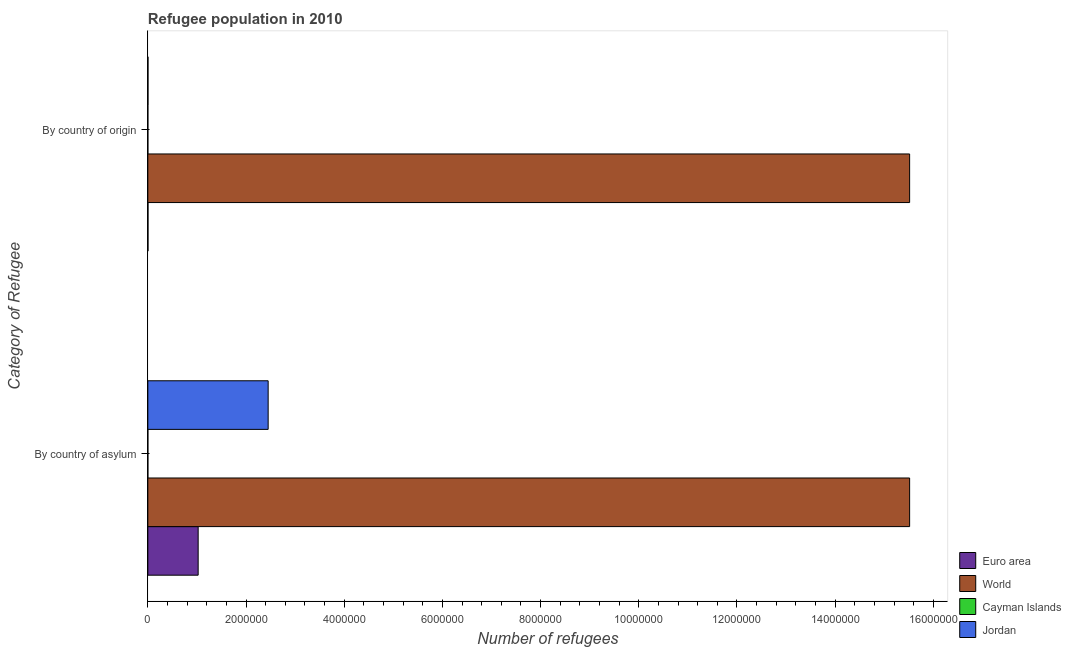How many groups of bars are there?
Ensure brevity in your answer.  2. Are the number of bars per tick equal to the number of legend labels?
Provide a succinct answer. Yes. Are the number of bars on each tick of the Y-axis equal?
Ensure brevity in your answer.  Yes. How many bars are there on the 2nd tick from the top?
Your answer should be compact. 4. How many bars are there on the 2nd tick from the bottom?
Your answer should be very brief. 4. What is the label of the 1st group of bars from the top?
Your response must be concise. By country of origin. What is the number of refugees by country of asylum in Cayman Islands?
Keep it short and to the point. 1. Across all countries, what is the maximum number of refugees by country of asylum?
Offer a terse response. 1.55e+07. Across all countries, what is the minimum number of refugees by country of origin?
Keep it short and to the point. 1. In which country was the number of refugees by country of origin minimum?
Make the answer very short. Cayman Islands. What is the total number of refugees by country of origin in the graph?
Ensure brevity in your answer.  1.55e+07. What is the difference between the number of refugees by country of asylum in Cayman Islands and that in World?
Ensure brevity in your answer.  -1.55e+07. What is the difference between the number of refugees by country of origin in World and the number of refugees by country of asylum in Cayman Islands?
Give a very brief answer. 1.55e+07. What is the average number of refugees by country of asylum per country?
Keep it short and to the point. 4.75e+06. What is the difference between the number of refugees by country of origin and number of refugees by country of asylum in Jordan?
Provide a succinct answer. -2.45e+06. In how many countries, is the number of refugees by country of origin greater than 14400000 ?
Provide a succinct answer. 1. What is the ratio of the number of refugees by country of origin in Jordan to that in Cayman Islands?
Your response must be concise. 2254. What does the 1st bar from the top in By country of origin represents?
Your answer should be very brief. Jordan. How many bars are there?
Your response must be concise. 8. How many countries are there in the graph?
Keep it short and to the point. 4. What is the difference between two consecutive major ticks on the X-axis?
Keep it short and to the point. 2.00e+06. Are the values on the major ticks of X-axis written in scientific E-notation?
Provide a short and direct response. No. Does the graph contain any zero values?
Your answer should be compact. No. How are the legend labels stacked?
Offer a terse response. Vertical. What is the title of the graph?
Make the answer very short. Refugee population in 2010. What is the label or title of the X-axis?
Make the answer very short. Number of refugees. What is the label or title of the Y-axis?
Your response must be concise. Category of Refugee. What is the Number of refugees in Euro area in By country of asylum?
Your answer should be compact. 1.02e+06. What is the Number of refugees in World in By country of asylum?
Offer a very short reply. 1.55e+07. What is the Number of refugees in Jordan in By country of asylum?
Offer a terse response. 2.45e+06. What is the Number of refugees of Euro area in By country of origin?
Make the answer very short. 2272. What is the Number of refugees in World in By country of origin?
Make the answer very short. 1.55e+07. What is the Number of refugees in Cayman Islands in By country of origin?
Make the answer very short. 1. What is the Number of refugees of Jordan in By country of origin?
Your answer should be very brief. 2254. Across all Category of Refugee, what is the maximum Number of refugees of Euro area?
Offer a very short reply. 1.02e+06. Across all Category of Refugee, what is the maximum Number of refugees in World?
Your answer should be very brief. 1.55e+07. Across all Category of Refugee, what is the maximum Number of refugees of Cayman Islands?
Keep it short and to the point. 1. Across all Category of Refugee, what is the maximum Number of refugees in Jordan?
Offer a terse response. 2.45e+06. Across all Category of Refugee, what is the minimum Number of refugees of Euro area?
Make the answer very short. 2272. Across all Category of Refugee, what is the minimum Number of refugees in World?
Provide a succinct answer. 1.55e+07. Across all Category of Refugee, what is the minimum Number of refugees of Cayman Islands?
Offer a very short reply. 1. Across all Category of Refugee, what is the minimum Number of refugees in Jordan?
Your answer should be compact. 2254. What is the total Number of refugees in Euro area in the graph?
Give a very brief answer. 1.03e+06. What is the total Number of refugees in World in the graph?
Offer a terse response. 3.10e+07. What is the total Number of refugees of Cayman Islands in the graph?
Offer a terse response. 2. What is the total Number of refugees of Jordan in the graph?
Give a very brief answer. 2.45e+06. What is the difference between the Number of refugees in Euro area in By country of asylum and that in By country of origin?
Keep it short and to the point. 1.02e+06. What is the difference between the Number of refugees in World in By country of asylum and that in By country of origin?
Give a very brief answer. 0. What is the difference between the Number of refugees in Jordan in By country of asylum and that in By country of origin?
Your response must be concise. 2.45e+06. What is the difference between the Number of refugees of Euro area in By country of asylum and the Number of refugees of World in By country of origin?
Provide a short and direct response. -1.45e+07. What is the difference between the Number of refugees of Euro area in By country of asylum and the Number of refugees of Cayman Islands in By country of origin?
Your answer should be compact. 1.02e+06. What is the difference between the Number of refugees in Euro area in By country of asylum and the Number of refugees in Jordan in By country of origin?
Make the answer very short. 1.02e+06. What is the difference between the Number of refugees of World in By country of asylum and the Number of refugees of Cayman Islands in By country of origin?
Offer a terse response. 1.55e+07. What is the difference between the Number of refugees in World in By country of asylum and the Number of refugees in Jordan in By country of origin?
Your answer should be compact. 1.55e+07. What is the difference between the Number of refugees of Cayman Islands in By country of asylum and the Number of refugees of Jordan in By country of origin?
Provide a short and direct response. -2253. What is the average Number of refugees of Euro area per Category of Refugee?
Your answer should be compact. 5.14e+05. What is the average Number of refugees of World per Category of Refugee?
Make the answer very short. 1.55e+07. What is the average Number of refugees of Cayman Islands per Category of Refugee?
Provide a succinct answer. 1. What is the average Number of refugees in Jordan per Category of Refugee?
Offer a very short reply. 1.23e+06. What is the difference between the Number of refugees of Euro area and Number of refugees of World in By country of asylum?
Give a very brief answer. -1.45e+07. What is the difference between the Number of refugees of Euro area and Number of refugees of Cayman Islands in By country of asylum?
Provide a short and direct response. 1.02e+06. What is the difference between the Number of refugees in Euro area and Number of refugees in Jordan in By country of asylum?
Your answer should be compact. -1.43e+06. What is the difference between the Number of refugees in World and Number of refugees in Cayman Islands in By country of asylum?
Keep it short and to the point. 1.55e+07. What is the difference between the Number of refugees in World and Number of refugees in Jordan in By country of asylum?
Offer a very short reply. 1.31e+07. What is the difference between the Number of refugees of Cayman Islands and Number of refugees of Jordan in By country of asylum?
Give a very brief answer. -2.45e+06. What is the difference between the Number of refugees of Euro area and Number of refugees of World in By country of origin?
Ensure brevity in your answer.  -1.55e+07. What is the difference between the Number of refugees of Euro area and Number of refugees of Cayman Islands in By country of origin?
Provide a short and direct response. 2271. What is the difference between the Number of refugees in World and Number of refugees in Cayman Islands in By country of origin?
Provide a short and direct response. 1.55e+07. What is the difference between the Number of refugees in World and Number of refugees in Jordan in By country of origin?
Offer a very short reply. 1.55e+07. What is the difference between the Number of refugees in Cayman Islands and Number of refugees in Jordan in By country of origin?
Keep it short and to the point. -2253. What is the ratio of the Number of refugees of Euro area in By country of asylum to that in By country of origin?
Offer a very short reply. 451.05. What is the ratio of the Number of refugees in Jordan in By country of asylum to that in By country of origin?
Provide a succinct answer. 1087.13. What is the difference between the highest and the second highest Number of refugees in Euro area?
Ensure brevity in your answer.  1.02e+06. What is the difference between the highest and the second highest Number of refugees of World?
Offer a very short reply. 0. What is the difference between the highest and the second highest Number of refugees in Cayman Islands?
Make the answer very short. 0. What is the difference between the highest and the second highest Number of refugees in Jordan?
Your answer should be very brief. 2.45e+06. What is the difference between the highest and the lowest Number of refugees in Euro area?
Your response must be concise. 1.02e+06. What is the difference between the highest and the lowest Number of refugees of World?
Provide a succinct answer. 0. What is the difference between the highest and the lowest Number of refugees of Jordan?
Your response must be concise. 2.45e+06. 